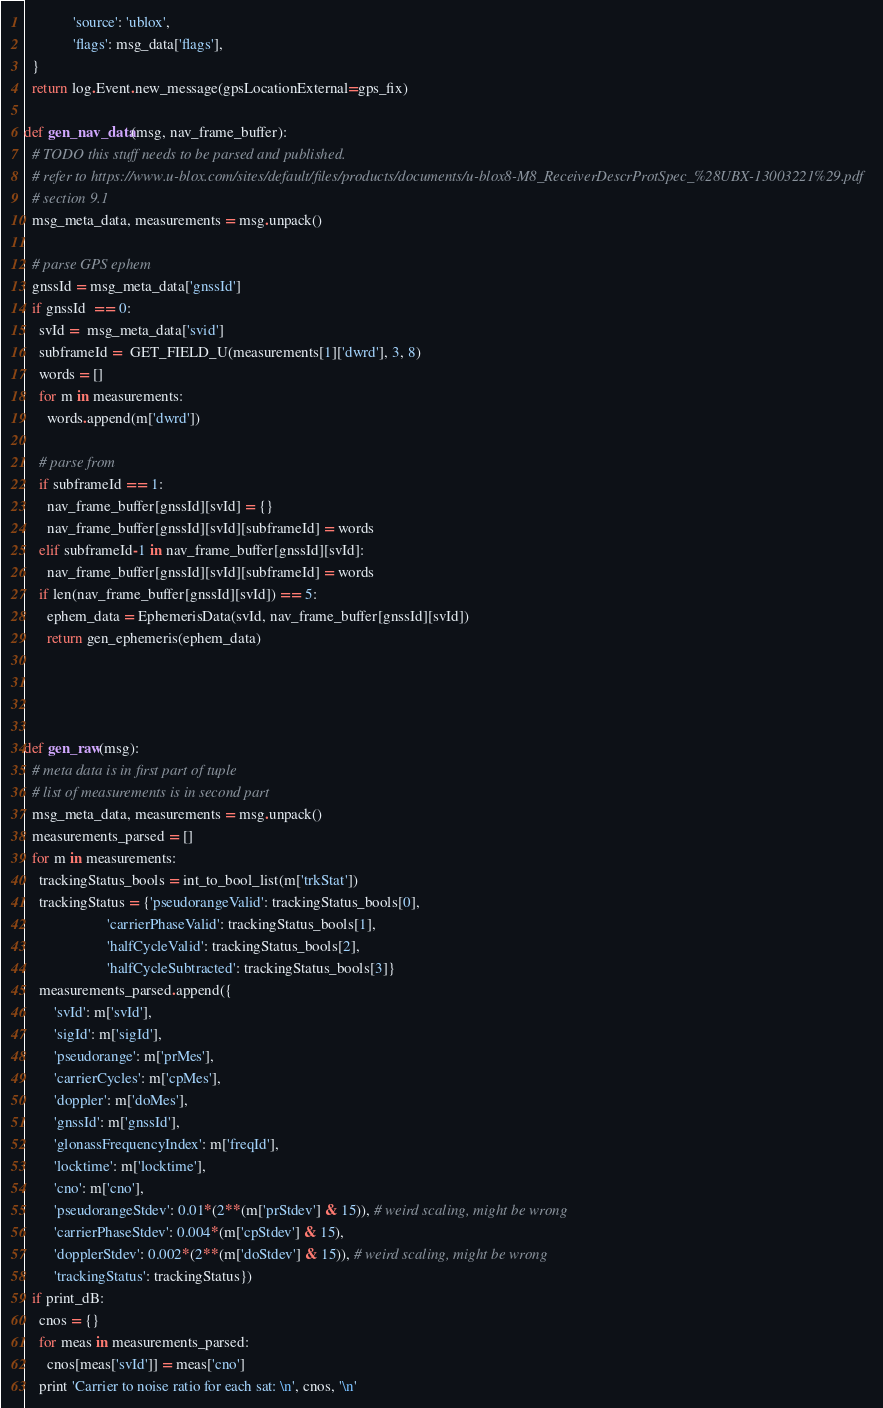<code> <loc_0><loc_0><loc_500><loc_500><_Python_>             'source': 'ublox',
             'flags': msg_data['flags'],
  }
  return log.Event.new_message(gpsLocationExternal=gps_fix)

def gen_nav_data(msg, nav_frame_buffer):
  # TODO this stuff needs to be parsed and published.
  # refer to https://www.u-blox.com/sites/default/files/products/documents/u-blox8-M8_ReceiverDescrProtSpec_%28UBX-13003221%29.pdf
  # section 9.1
  msg_meta_data, measurements = msg.unpack()

  # parse GPS ephem
  gnssId = msg_meta_data['gnssId']
  if gnssId  == 0:
    svId =  msg_meta_data['svid']
    subframeId =  GET_FIELD_U(measurements[1]['dwrd'], 3, 8)
    words = []
    for m in measurements:
      words.append(m['dwrd'])

    # parse from
    if subframeId == 1:
      nav_frame_buffer[gnssId][svId] = {}
      nav_frame_buffer[gnssId][svId][subframeId] = words
    elif subframeId-1 in nav_frame_buffer[gnssId][svId]:
      nav_frame_buffer[gnssId][svId][subframeId] = words
    if len(nav_frame_buffer[gnssId][svId]) == 5:
      ephem_data = EphemerisData(svId, nav_frame_buffer[gnssId][svId])
      return gen_ephemeris(ephem_data)




def gen_raw(msg):
  # meta data is in first part of tuple
  # list of measurements is in second part
  msg_meta_data, measurements = msg.unpack()
  measurements_parsed = []
  for m in measurements:
    trackingStatus_bools = int_to_bool_list(m['trkStat'])
    trackingStatus = {'pseudorangeValid': trackingStatus_bools[0],
                      'carrierPhaseValid': trackingStatus_bools[1],
                      'halfCycleValid': trackingStatus_bools[2],
                      'halfCycleSubtracted': trackingStatus_bools[3]}
    measurements_parsed.append({
        'svId': m['svId'],
        'sigId': m['sigId'],
        'pseudorange': m['prMes'],
        'carrierCycles': m['cpMes'],
        'doppler': m['doMes'],
        'gnssId': m['gnssId'],
        'glonassFrequencyIndex': m['freqId'],
        'locktime': m['locktime'],
        'cno': m['cno'],
        'pseudorangeStdev': 0.01*(2**(m['prStdev'] & 15)), # weird scaling, might be wrong
        'carrierPhaseStdev': 0.004*(m['cpStdev'] & 15),
        'dopplerStdev': 0.002*(2**(m['doStdev'] & 15)), # weird scaling, might be wrong
        'trackingStatus': trackingStatus})
  if print_dB:
    cnos = {}
    for meas in measurements_parsed:
      cnos[meas['svId']] = meas['cno']
    print 'Carrier to noise ratio for each sat: \n', cnos, '\n'</code> 